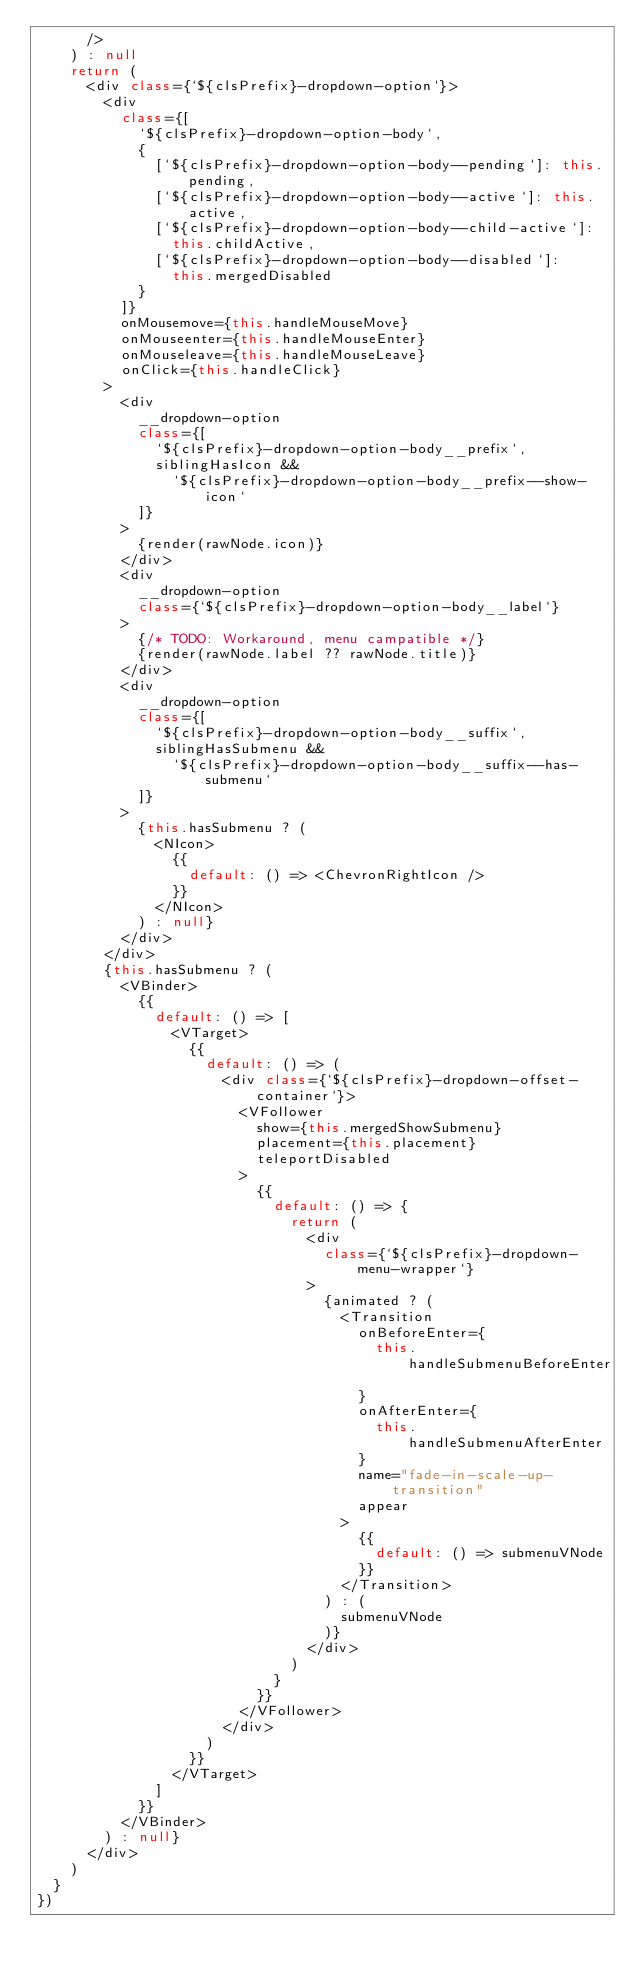<code> <loc_0><loc_0><loc_500><loc_500><_TypeScript_>      />
    ) : null
    return (
      <div class={`${clsPrefix}-dropdown-option`}>
        <div
          class={[
            `${clsPrefix}-dropdown-option-body`,
            {
              [`${clsPrefix}-dropdown-option-body--pending`]: this.pending,
              [`${clsPrefix}-dropdown-option-body--active`]: this.active,
              [`${clsPrefix}-dropdown-option-body--child-active`]:
                this.childActive,
              [`${clsPrefix}-dropdown-option-body--disabled`]:
                this.mergedDisabled
            }
          ]}
          onMousemove={this.handleMouseMove}
          onMouseenter={this.handleMouseEnter}
          onMouseleave={this.handleMouseLeave}
          onClick={this.handleClick}
        >
          <div
            __dropdown-option
            class={[
              `${clsPrefix}-dropdown-option-body__prefix`,
              siblingHasIcon &&
                `${clsPrefix}-dropdown-option-body__prefix--show-icon`
            ]}
          >
            {render(rawNode.icon)}
          </div>
          <div
            __dropdown-option
            class={`${clsPrefix}-dropdown-option-body__label`}
          >
            {/* TODO: Workaround, menu campatible */}
            {render(rawNode.label ?? rawNode.title)}
          </div>
          <div
            __dropdown-option
            class={[
              `${clsPrefix}-dropdown-option-body__suffix`,
              siblingHasSubmenu &&
                `${clsPrefix}-dropdown-option-body__suffix--has-submenu`
            ]}
          >
            {this.hasSubmenu ? (
              <NIcon>
                {{
                  default: () => <ChevronRightIcon />
                }}
              </NIcon>
            ) : null}
          </div>
        </div>
        {this.hasSubmenu ? (
          <VBinder>
            {{
              default: () => [
                <VTarget>
                  {{
                    default: () => (
                      <div class={`${clsPrefix}-dropdown-offset-container`}>
                        <VFollower
                          show={this.mergedShowSubmenu}
                          placement={this.placement}
                          teleportDisabled
                        >
                          {{
                            default: () => {
                              return (
                                <div
                                  class={`${clsPrefix}-dropdown-menu-wrapper`}
                                >
                                  {animated ? (
                                    <Transition
                                      onBeforeEnter={
                                        this.handleSubmenuBeforeEnter
                                      }
                                      onAfterEnter={
                                        this.handleSubmenuAfterEnter
                                      }
                                      name="fade-in-scale-up-transition"
                                      appear
                                    >
                                      {{
                                        default: () => submenuVNode
                                      }}
                                    </Transition>
                                  ) : (
                                    submenuVNode
                                  )}
                                </div>
                              )
                            }
                          }}
                        </VFollower>
                      </div>
                    )
                  }}
                </VTarget>
              ]
            }}
          </VBinder>
        ) : null}
      </div>
    )
  }
})
</code> 